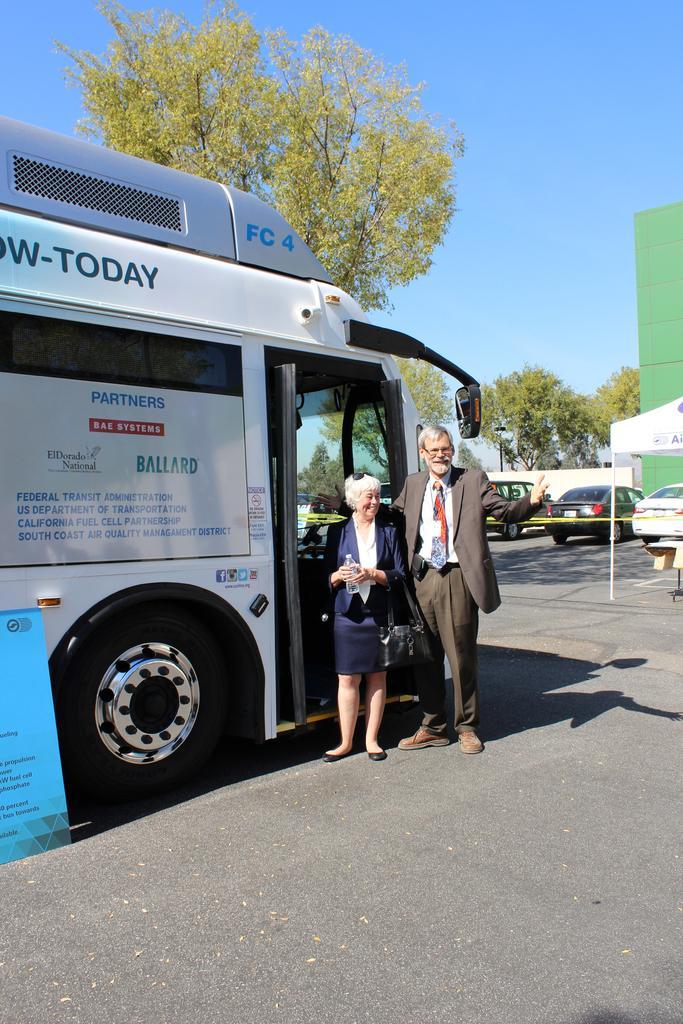Please provide a concise description of this image. In this image in the center there is one bus and two persons are standing, at the bottom there is road. And in the background there are trees, vehicles, buildings and at the top there is sky. 